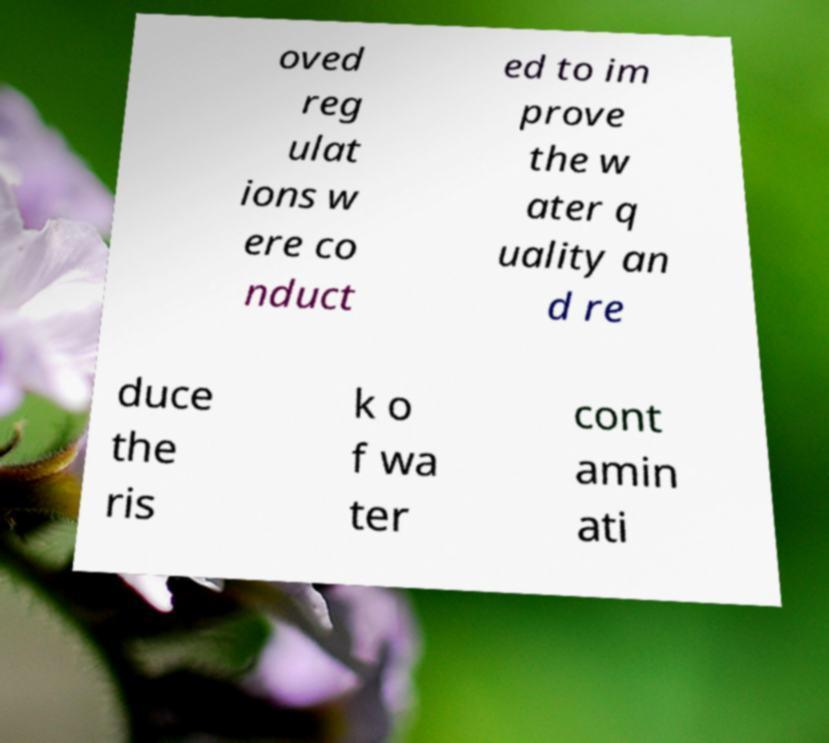Can you accurately transcribe the text from the provided image for me? oved reg ulat ions w ere co nduct ed to im prove the w ater q uality an d re duce the ris k o f wa ter cont amin ati 